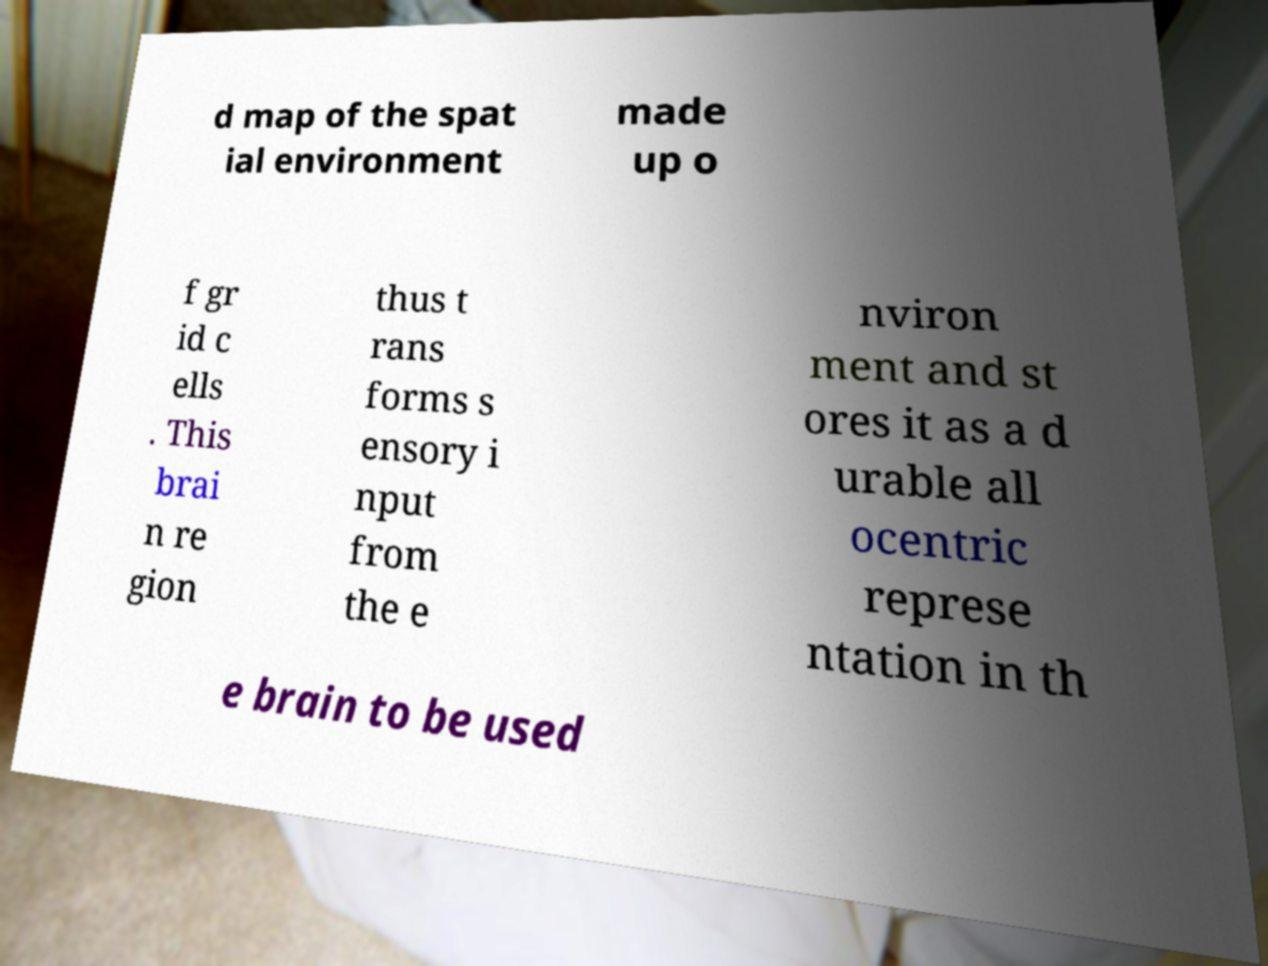Can you accurately transcribe the text from the provided image for me? d map of the spat ial environment made up o f gr id c ells . This brai n re gion thus t rans forms s ensory i nput from the e nviron ment and st ores it as a d urable all ocentric represe ntation in th e brain to be used 